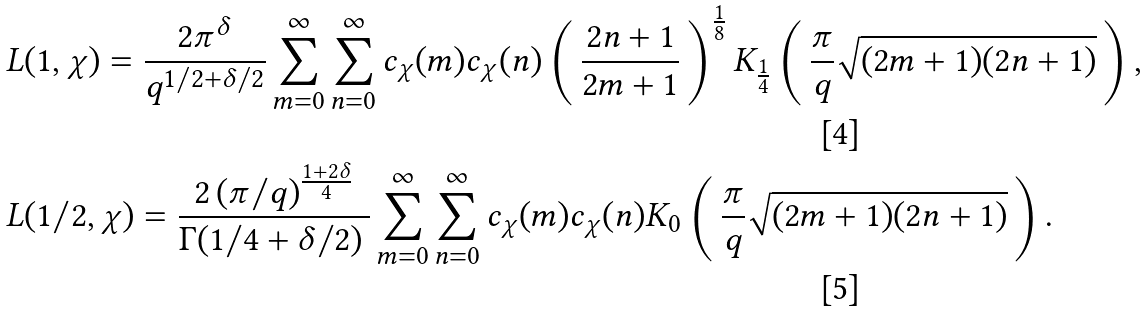Convert formula to latex. <formula><loc_0><loc_0><loc_500><loc_500>L & ( 1 , \chi ) = \frac { 2 \pi ^ { \delta } } { q ^ { 1 / 2 + \delta / 2 } } \sum _ { m = 0 } ^ { \infty } \sum _ { n = 0 } ^ { \infty } c _ { \chi } ( m ) c _ { \chi } ( n ) \left ( \, \frac { 2 n + 1 } { 2 m + 1 } \, \right ) ^ { \frac { 1 } { 8 } } K _ { \frac { 1 } { 4 } } \left ( \, \frac { \pi } { q } \sqrt { ( 2 m + 1 ) ( 2 n + 1 ) } \, \right ) , \quad \\ L & ( 1 / 2 , \chi ) = \frac { 2 \, ( \pi / q ) ^ { \frac { 1 + 2 \delta } { 4 } } } { \Gamma ( 1 / 4 + \delta / 2 ) \, } \sum _ { m = 0 } ^ { \infty } \sum _ { n = 0 } ^ { \infty } c _ { \chi } ( m ) c _ { \chi } ( n ) K _ { 0 } \left ( \, \frac { \pi } { q } \sqrt { ( 2 m + 1 ) ( 2 n + 1 ) } \, \right ) .</formula> 